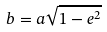Convert formula to latex. <formula><loc_0><loc_0><loc_500><loc_500>b = a \sqrt { 1 - e ^ { 2 } }</formula> 